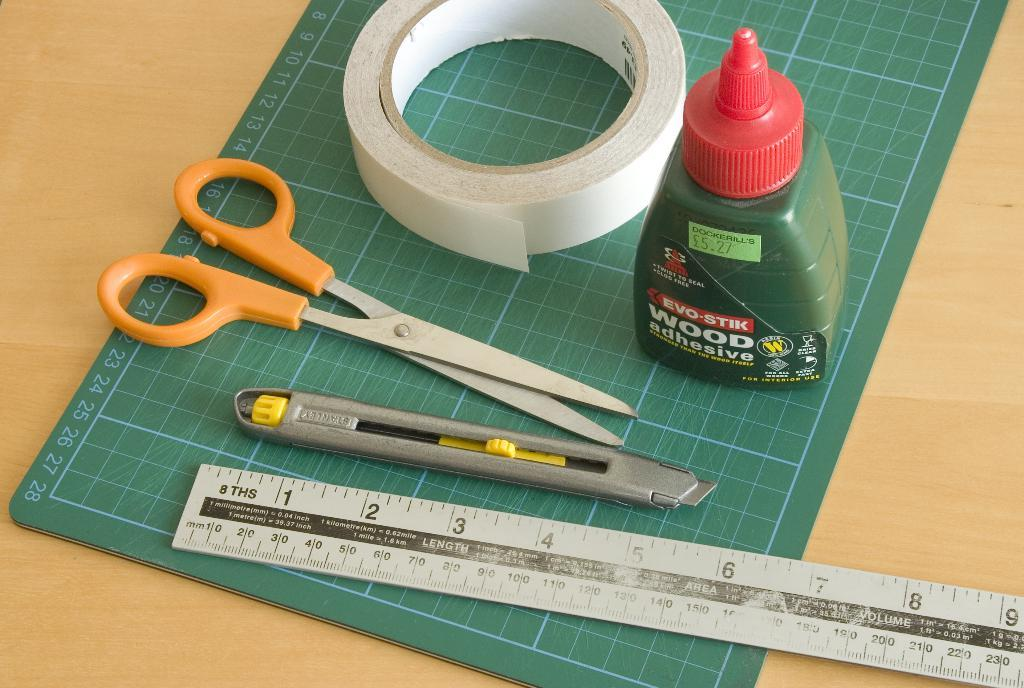<image>
Describe the image concisely. Evo-Stick wood adhesive sitting on a grid mat along with a ruler, scissor, tape, and cutter. 